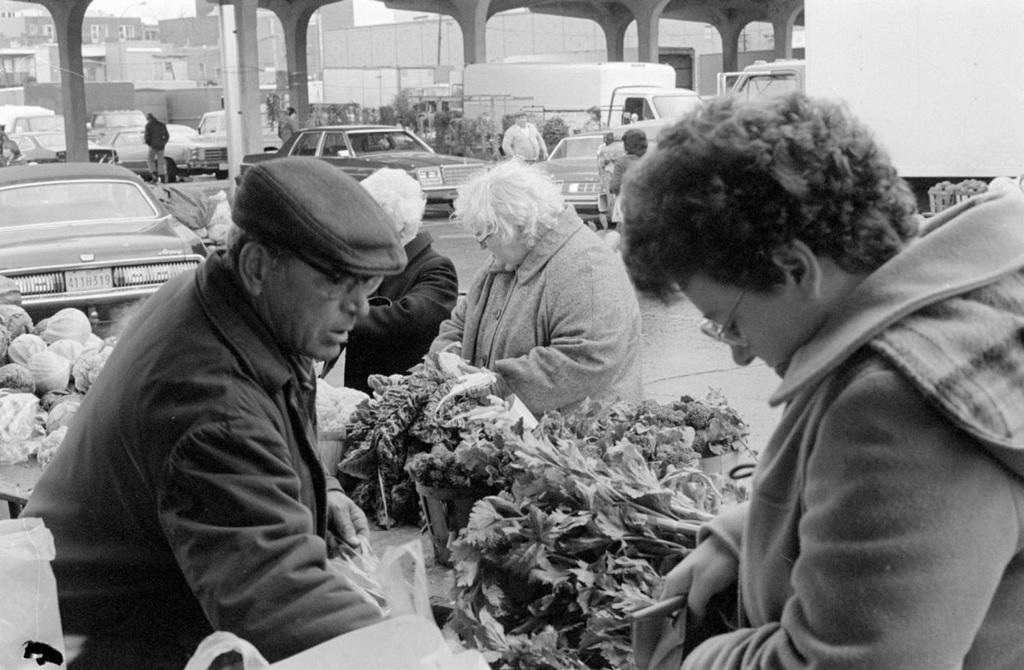How would you summarize this image in a sentence or two? In this image we can see many people. Few are wearing specs. One person is wearing specs. One person is wearing cap. Also there are vegetables. In the back there are buildings. Also there is a bridge with pillars. In the background there are buildings. 